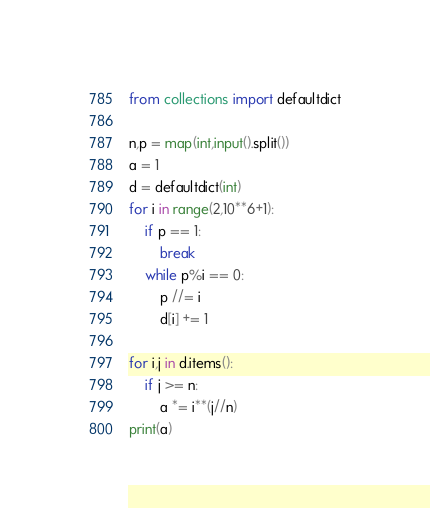<code> <loc_0><loc_0><loc_500><loc_500><_Python_>from collections import defaultdict

n,p = map(int,input().split())
a = 1
d = defaultdict(int)
for i in range(2,10**6+1):
    if p == 1:
        break
    while p%i == 0:
        p //= i
        d[i] += 1

for i,j in d.items():
    if j >= n:
        a *= i**(j//n)
print(a)


</code> 